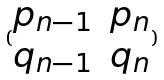Convert formula to latex. <formula><loc_0><loc_0><loc_500><loc_500>( \begin{matrix} p _ { n - 1 } & p _ { n } \\ q _ { n - 1 } & q _ { n } \end{matrix} )</formula> 